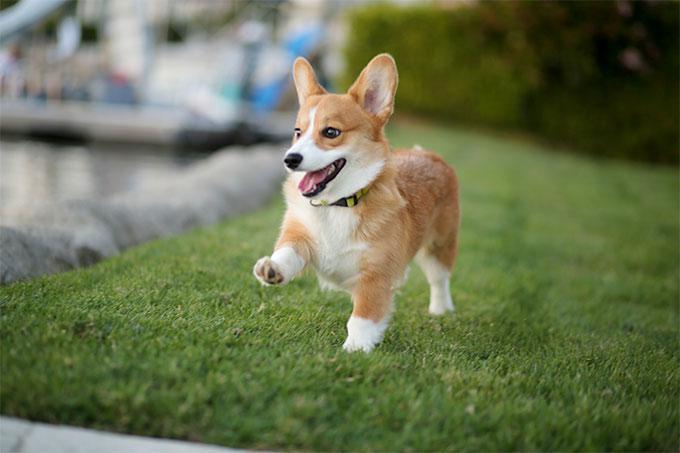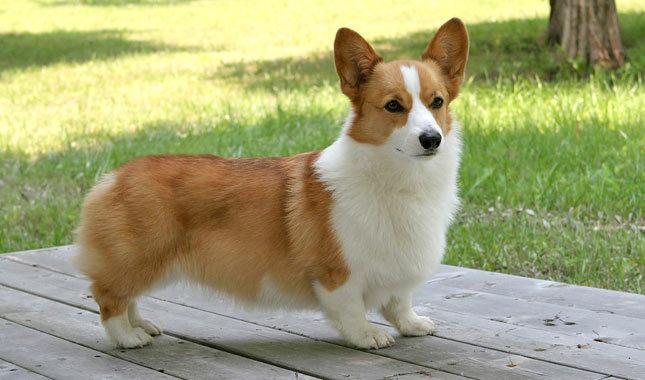The first image is the image on the left, the second image is the image on the right. Examine the images to the left and right. Is the description "There is a dog in the right image on a wooden surface." accurate? Answer yes or no. Yes. The first image is the image on the left, the second image is the image on the right. Analyze the images presented: Is the assertion "One of the dogs is wearing a collar with no charms." valid? Answer yes or no. Yes. The first image is the image on the left, the second image is the image on the right. Analyze the images presented: Is the assertion "The dog in the image on the right is on grass." valid? Answer yes or no. No. 